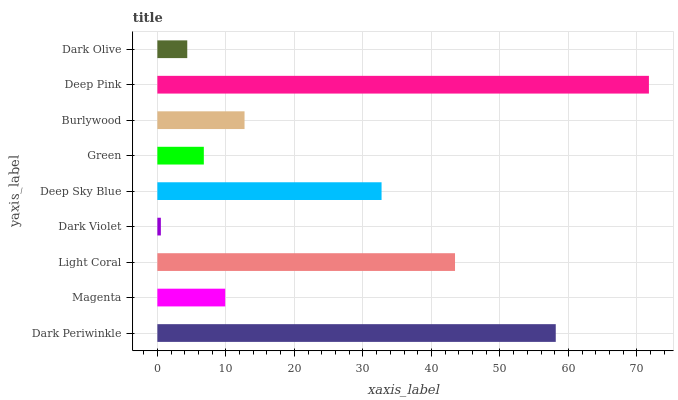Is Dark Violet the minimum?
Answer yes or no. Yes. Is Deep Pink the maximum?
Answer yes or no. Yes. Is Magenta the minimum?
Answer yes or no. No. Is Magenta the maximum?
Answer yes or no. No. Is Dark Periwinkle greater than Magenta?
Answer yes or no. Yes. Is Magenta less than Dark Periwinkle?
Answer yes or no. Yes. Is Magenta greater than Dark Periwinkle?
Answer yes or no. No. Is Dark Periwinkle less than Magenta?
Answer yes or no. No. Is Burlywood the high median?
Answer yes or no. Yes. Is Burlywood the low median?
Answer yes or no. Yes. Is Dark Periwinkle the high median?
Answer yes or no. No. Is Dark Periwinkle the low median?
Answer yes or no. No. 